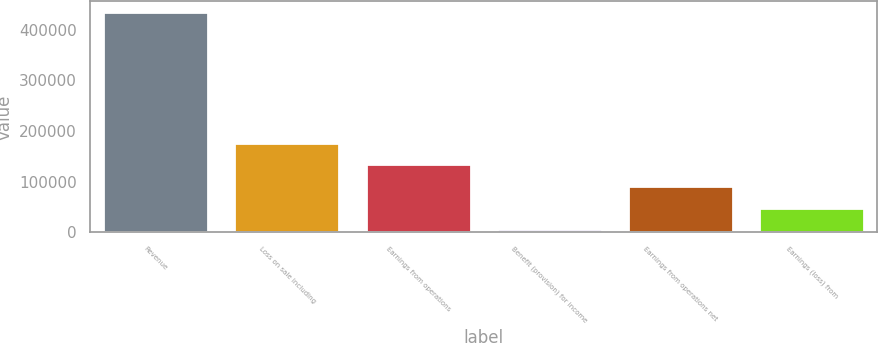<chart> <loc_0><loc_0><loc_500><loc_500><bar_chart><fcel>Revenue<fcel>Loss on sale including<fcel>Earnings from operations<fcel>Benefit (provision) for income<fcel>Earnings from operations net<fcel>Earnings (loss) from<nl><fcel>434460<fcel>177233<fcel>134362<fcel>5748<fcel>91490.4<fcel>48619.2<nl></chart> 